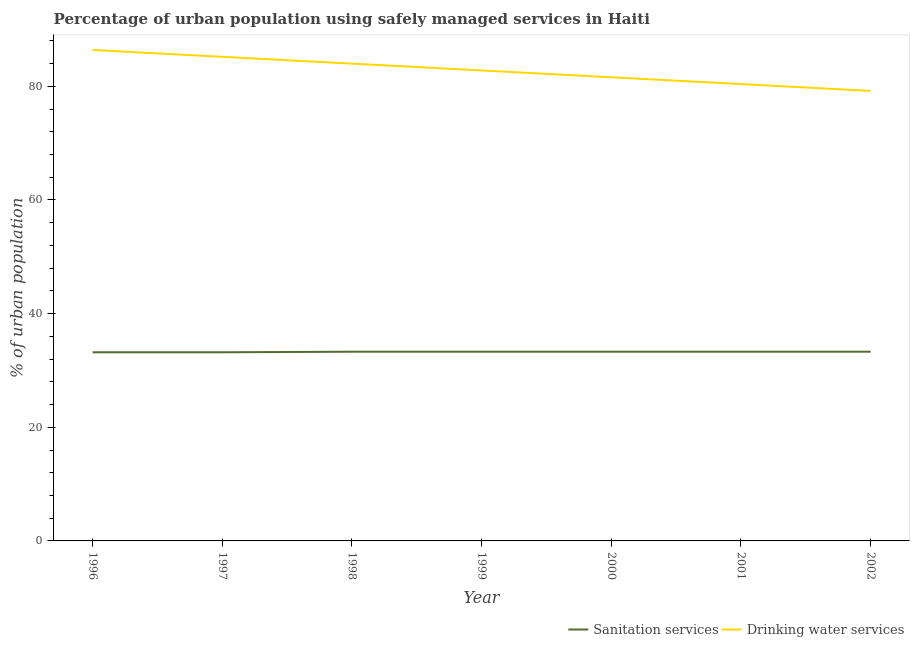Does the line corresponding to percentage of urban population who used sanitation services intersect with the line corresponding to percentage of urban population who used drinking water services?
Offer a very short reply. No. What is the percentage of urban population who used drinking water services in 1996?
Ensure brevity in your answer.  86.4. Across all years, what is the maximum percentage of urban population who used sanitation services?
Provide a short and direct response. 33.3. Across all years, what is the minimum percentage of urban population who used drinking water services?
Provide a short and direct response. 79.2. In which year was the percentage of urban population who used drinking water services maximum?
Provide a succinct answer. 1996. In which year was the percentage of urban population who used sanitation services minimum?
Provide a short and direct response. 1996. What is the total percentage of urban population who used sanitation services in the graph?
Offer a very short reply. 232.9. What is the difference between the percentage of urban population who used drinking water services in 1996 and that in 2002?
Provide a short and direct response. 7.2. What is the difference between the percentage of urban population who used drinking water services in 1998 and the percentage of urban population who used sanitation services in 2000?
Your response must be concise. 50.7. What is the average percentage of urban population who used drinking water services per year?
Offer a very short reply. 82.8. In the year 1996, what is the difference between the percentage of urban population who used sanitation services and percentage of urban population who used drinking water services?
Provide a short and direct response. -53.2. What is the ratio of the percentage of urban population who used drinking water services in 1996 to that in 1998?
Make the answer very short. 1.03. Is the percentage of urban population who used drinking water services in 1997 less than that in 1998?
Ensure brevity in your answer.  No. Is the difference between the percentage of urban population who used sanitation services in 1999 and 2002 greater than the difference between the percentage of urban population who used drinking water services in 1999 and 2002?
Offer a terse response. No. What is the difference between the highest and the second highest percentage of urban population who used drinking water services?
Give a very brief answer. 1.2. What is the difference between the highest and the lowest percentage of urban population who used drinking water services?
Give a very brief answer. 7.2. In how many years, is the percentage of urban population who used sanitation services greater than the average percentage of urban population who used sanitation services taken over all years?
Your answer should be very brief. 5. Is the sum of the percentage of urban population who used sanitation services in 1999 and 2001 greater than the maximum percentage of urban population who used drinking water services across all years?
Provide a short and direct response. No. Does the percentage of urban population who used drinking water services monotonically increase over the years?
Keep it short and to the point. No. How many lines are there?
Ensure brevity in your answer.  2. How many years are there in the graph?
Your answer should be very brief. 7. What is the difference between two consecutive major ticks on the Y-axis?
Offer a very short reply. 20. Does the graph contain grids?
Provide a succinct answer. No. How many legend labels are there?
Your answer should be compact. 2. How are the legend labels stacked?
Give a very brief answer. Horizontal. What is the title of the graph?
Your answer should be very brief. Percentage of urban population using safely managed services in Haiti. Does "Sanitation services" appear as one of the legend labels in the graph?
Make the answer very short. Yes. What is the label or title of the Y-axis?
Your answer should be compact. % of urban population. What is the % of urban population of Sanitation services in 1996?
Provide a short and direct response. 33.2. What is the % of urban population in Drinking water services in 1996?
Keep it short and to the point. 86.4. What is the % of urban population in Sanitation services in 1997?
Your answer should be compact. 33.2. What is the % of urban population in Drinking water services in 1997?
Keep it short and to the point. 85.2. What is the % of urban population of Sanitation services in 1998?
Provide a short and direct response. 33.3. What is the % of urban population of Sanitation services in 1999?
Offer a very short reply. 33.3. What is the % of urban population of Drinking water services in 1999?
Your response must be concise. 82.8. What is the % of urban population in Sanitation services in 2000?
Offer a very short reply. 33.3. What is the % of urban population in Drinking water services in 2000?
Provide a short and direct response. 81.6. What is the % of urban population of Sanitation services in 2001?
Offer a very short reply. 33.3. What is the % of urban population of Drinking water services in 2001?
Ensure brevity in your answer.  80.4. What is the % of urban population of Sanitation services in 2002?
Offer a terse response. 33.3. What is the % of urban population in Drinking water services in 2002?
Offer a very short reply. 79.2. Across all years, what is the maximum % of urban population of Sanitation services?
Offer a very short reply. 33.3. Across all years, what is the maximum % of urban population of Drinking water services?
Make the answer very short. 86.4. Across all years, what is the minimum % of urban population of Sanitation services?
Give a very brief answer. 33.2. Across all years, what is the minimum % of urban population in Drinking water services?
Your response must be concise. 79.2. What is the total % of urban population in Sanitation services in the graph?
Offer a very short reply. 232.9. What is the total % of urban population of Drinking water services in the graph?
Make the answer very short. 579.6. What is the difference between the % of urban population of Sanitation services in 1996 and that in 1999?
Your response must be concise. -0.1. What is the difference between the % of urban population of Drinking water services in 1996 and that in 1999?
Your answer should be very brief. 3.6. What is the difference between the % of urban population in Sanitation services in 1996 and that in 2000?
Your answer should be very brief. -0.1. What is the difference between the % of urban population in Drinking water services in 1996 and that in 2000?
Provide a succinct answer. 4.8. What is the difference between the % of urban population of Sanitation services in 1996 and that in 2002?
Provide a succinct answer. -0.1. What is the difference between the % of urban population in Drinking water services in 1996 and that in 2002?
Offer a terse response. 7.2. What is the difference between the % of urban population of Sanitation services in 1997 and that in 1998?
Your answer should be very brief. -0.1. What is the difference between the % of urban population of Drinking water services in 1997 and that in 1998?
Keep it short and to the point. 1.2. What is the difference between the % of urban population in Sanitation services in 1997 and that in 1999?
Your answer should be very brief. -0.1. What is the difference between the % of urban population in Sanitation services in 1997 and that in 2000?
Your response must be concise. -0.1. What is the difference between the % of urban population in Sanitation services in 1997 and that in 2001?
Offer a terse response. -0.1. What is the difference between the % of urban population of Drinking water services in 1997 and that in 2001?
Offer a very short reply. 4.8. What is the difference between the % of urban population of Sanitation services in 1997 and that in 2002?
Your response must be concise. -0.1. What is the difference between the % of urban population of Drinking water services in 1997 and that in 2002?
Provide a succinct answer. 6. What is the difference between the % of urban population of Sanitation services in 1998 and that in 1999?
Your response must be concise. 0. What is the difference between the % of urban population in Drinking water services in 1998 and that in 2000?
Keep it short and to the point. 2.4. What is the difference between the % of urban population in Sanitation services in 1998 and that in 2002?
Make the answer very short. 0. What is the difference between the % of urban population in Sanitation services in 1999 and that in 2000?
Ensure brevity in your answer.  0. What is the difference between the % of urban population in Drinking water services in 1999 and that in 2000?
Keep it short and to the point. 1.2. What is the difference between the % of urban population of Sanitation services in 1999 and that in 2001?
Keep it short and to the point. 0. What is the difference between the % of urban population of Drinking water services in 1999 and that in 2001?
Make the answer very short. 2.4. What is the difference between the % of urban population in Sanitation services in 2001 and that in 2002?
Your answer should be compact. 0. What is the difference between the % of urban population of Sanitation services in 1996 and the % of urban population of Drinking water services in 1997?
Provide a short and direct response. -52. What is the difference between the % of urban population in Sanitation services in 1996 and the % of urban population in Drinking water services in 1998?
Your response must be concise. -50.8. What is the difference between the % of urban population in Sanitation services in 1996 and the % of urban population in Drinking water services in 1999?
Your answer should be compact. -49.6. What is the difference between the % of urban population in Sanitation services in 1996 and the % of urban population in Drinking water services in 2000?
Offer a very short reply. -48.4. What is the difference between the % of urban population in Sanitation services in 1996 and the % of urban population in Drinking water services in 2001?
Your answer should be very brief. -47.2. What is the difference between the % of urban population of Sanitation services in 1996 and the % of urban population of Drinking water services in 2002?
Provide a succinct answer. -46. What is the difference between the % of urban population of Sanitation services in 1997 and the % of urban population of Drinking water services in 1998?
Offer a very short reply. -50.8. What is the difference between the % of urban population in Sanitation services in 1997 and the % of urban population in Drinking water services in 1999?
Your answer should be compact. -49.6. What is the difference between the % of urban population of Sanitation services in 1997 and the % of urban population of Drinking water services in 2000?
Your response must be concise. -48.4. What is the difference between the % of urban population of Sanitation services in 1997 and the % of urban population of Drinking water services in 2001?
Provide a succinct answer. -47.2. What is the difference between the % of urban population in Sanitation services in 1997 and the % of urban population in Drinking water services in 2002?
Give a very brief answer. -46. What is the difference between the % of urban population in Sanitation services in 1998 and the % of urban population in Drinking water services in 1999?
Ensure brevity in your answer.  -49.5. What is the difference between the % of urban population of Sanitation services in 1998 and the % of urban population of Drinking water services in 2000?
Offer a terse response. -48.3. What is the difference between the % of urban population of Sanitation services in 1998 and the % of urban population of Drinking water services in 2001?
Your response must be concise. -47.1. What is the difference between the % of urban population of Sanitation services in 1998 and the % of urban population of Drinking water services in 2002?
Offer a terse response. -45.9. What is the difference between the % of urban population of Sanitation services in 1999 and the % of urban population of Drinking water services in 2000?
Provide a short and direct response. -48.3. What is the difference between the % of urban population of Sanitation services in 1999 and the % of urban population of Drinking water services in 2001?
Make the answer very short. -47.1. What is the difference between the % of urban population in Sanitation services in 1999 and the % of urban population in Drinking water services in 2002?
Provide a succinct answer. -45.9. What is the difference between the % of urban population in Sanitation services in 2000 and the % of urban population in Drinking water services in 2001?
Offer a very short reply. -47.1. What is the difference between the % of urban population of Sanitation services in 2000 and the % of urban population of Drinking water services in 2002?
Provide a short and direct response. -45.9. What is the difference between the % of urban population in Sanitation services in 2001 and the % of urban population in Drinking water services in 2002?
Make the answer very short. -45.9. What is the average % of urban population of Sanitation services per year?
Your answer should be very brief. 33.27. What is the average % of urban population of Drinking water services per year?
Make the answer very short. 82.8. In the year 1996, what is the difference between the % of urban population in Sanitation services and % of urban population in Drinking water services?
Your response must be concise. -53.2. In the year 1997, what is the difference between the % of urban population in Sanitation services and % of urban population in Drinking water services?
Ensure brevity in your answer.  -52. In the year 1998, what is the difference between the % of urban population in Sanitation services and % of urban population in Drinking water services?
Provide a short and direct response. -50.7. In the year 1999, what is the difference between the % of urban population of Sanitation services and % of urban population of Drinking water services?
Your response must be concise. -49.5. In the year 2000, what is the difference between the % of urban population in Sanitation services and % of urban population in Drinking water services?
Keep it short and to the point. -48.3. In the year 2001, what is the difference between the % of urban population in Sanitation services and % of urban population in Drinking water services?
Your answer should be compact. -47.1. In the year 2002, what is the difference between the % of urban population of Sanitation services and % of urban population of Drinking water services?
Your answer should be very brief. -45.9. What is the ratio of the % of urban population of Sanitation services in 1996 to that in 1997?
Make the answer very short. 1. What is the ratio of the % of urban population of Drinking water services in 1996 to that in 1997?
Ensure brevity in your answer.  1.01. What is the ratio of the % of urban population in Sanitation services in 1996 to that in 1998?
Your answer should be compact. 1. What is the ratio of the % of urban population of Drinking water services in 1996 to that in 1998?
Give a very brief answer. 1.03. What is the ratio of the % of urban population of Sanitation services in 1996 to that in 1999?
Your answer should be compact. 1. What is the ratio of the % of urban population of Drinking water services in 1996 to that in 1999?
Give a very brief answer. 1.04. What is the ratio of the % of urban population of Sanitation services in 1996 to that in 2000?
Your answer should be very brief. 1. What is the ratio of the % of urban population in Drinking water services in 1996 to that in 2000?
Keep it short and to the point. 1.06. What is the ratio of the % of urban population in Drinking water services in 1996 to that in 2001?
Offer a terse response. 1.07. What is the ratio of the % of urban population of Sanitation services in 1996 to that in 2002?
Keep it short and to the point. 1. What is the ratio of the % of urban population in Drinking water services in 1996 to that in 2002?
Give a very brief answer. 1.09. What is the ratio of the % of urban population of Drinking water services in 1997 to that in 1998?
Your answer should be very brief. 1.01. What is the ratio of the % of urban population of Sanitation services in 1997 to that in 1999?
Provide a succinct answer. 1. What is the ratio of the % of urban population of Drinking water services in 1997 to that in 2000?
Your response must be concise. 1.04. What is the ratio of the % of urban population of Drinking water services in 1997 to that in 2001?
Offer a very short reply. 1.06. What is the ratio of the % of urban population of Sanitation services in 1997 to that in 2002?
Your answer should be very brief. 1. What is the ratio of the % of urban population in Drinking water services in 1997 to that in 2002?
Your answer should be compact. 1.08. What is the ratio of the % of urban population in Drinking water services in 1998 to that in 1999?
Make the answer very short. 1.01. What is the ratio of the % of urban population in Drinking water services in 1998 to that in 2000?
Provide a short and direct response. 1.03. What is the ratio of the % of urban population of Sanitation services in 1998 to that in 2001?
Provide a short and direct response. 1. What is the ratio of the % of urban population in Drinking water services in 1998 to that in 2001?
Ensure brevity in your answer.  1.04. What is the ratio of the % of urban population of Sanitation services in 1998 to that in 2002?
Provide a short and direct response. 1. What is the ratio of the % of urban population of Drinking water services in 1998 to that in 2002?
Keep it short and to the point. 1.06. What is the ratio of the % of urban population in Sanitation services in 1999 to that in 2000?
Your answer should be compact. 1. What is the ratio of the % of urban population in Drinking water services in 1999 to that in 2000?
Keep it short and to the point. 1.01. What is the ratio of the % of urban population in Sanitation services in 1999 to that in 2001?
Your answer should be very brief. 1. What is the ratio of the % of urban population in Drinking water services in 1999 to that in 2001?
Your response must be concise. 1.03. What is the ratio of the % of urban population of Drinking water services in 1999 to that in 2002?
Provide a succinct answer. 1.05. What is the ratio of the % of urban population in Sanitation services in 2000 to that in 2001?
Keep it short and to the point. 1. What is the ratio of the % of urban population of Drinking water services in 2000 to that in 2001?
Keep it short and to the point. 1.01. What is the ratio of the % of urban population in Drinking water services in 2000 to that in 2002?
Your answer should be compact. 1.03. What is the ratio of the % of urban population in Sanitation services in 2001 to that in 2002?
Ensure brevity in your answer.  1. What is the ratio of the % of urban population in Drinking water services in 2001 to that in 2002?
Give a very brief answer. 1.02. What is the difference between the highest and the second highest % of urban population in Sanitation services?
Your answer should be compact. 0. What is the difference between the highest and the lowest % of urban population of Sanitation services?
Keep it short and to the point. 0.1. What is the difference between the highest and the lowest % of urban population of Drinking water services?
Provide a succinct answer. 7.2. 